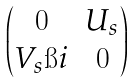<formula> <loc_0><loc_0><loc_500><loc_500>\begin{pmatrix} 0 & U _ { s } \\ V _ { s } \i i & 0 \end{pmatrix}</formula> 